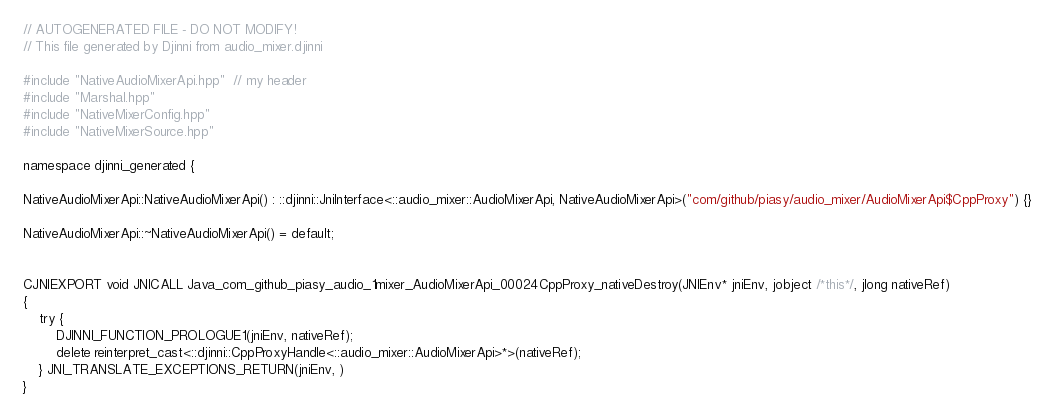Convert code to text. <code><loc_0><loc_0><loc_500><loc_500><_C++_>// AUTOGENERATED FILE - DO NOT MODIFY!
// This file generated by Djinni from audio_mixer.djinni

#include "NativeAudioMixerApi.hpp"  // my header
#include "Marshal.hpp"
#include "NativeMixerConfig.hpp"
#include "NativeMixerSource.hpp"

namespace djinni_generated {

NativeAudioMixerApi::NativeAudioMixerApi() : ::djinni::JniInterface<::audio_mixer::AudioMixerApi, NativeAudioMixerApi>("com/github/piasy/audio_mixer/AudioMixerApi$CppProxy") {}

NativeAudioMixerApi::~NativeAudioMixerApi() = default;


CJNIEXPORT void JNICALL Java_com_github_piasy_audio_1mixer_AudioMixerApi_00024CppProxy_nativeDestroy(JNIEnv* jniEnv, jobject /*this*/, jlong nativeRef)
{
    try {
        DJINNI_FUNCTION_PROLOGUE1(jniEnv, nativeRef);
        delete reinterpret_cast<::djinni::CppProxyHandle<::audio_mixer::AudioMixerApi>*>(nativeRef);
    } JNI_TRANSLATE_EXCEPTIONS_RETURN(jniEnv, )
}
</code> 